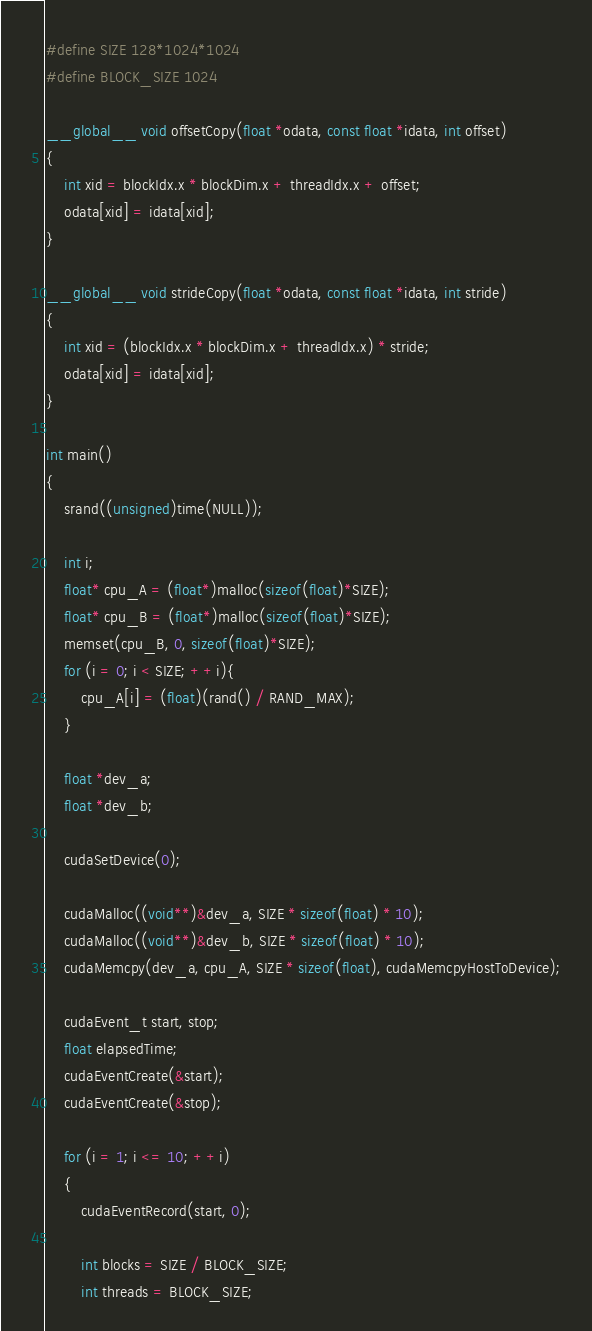Convert code to text. <code><loc_0><loc_0><loc_500><loc_500><_Cuda_>
#define SIZE 128*1024*1024
#define BLOCK_SIZE 1024

__global__ void offsetCopy(float *odata, const float *idata, int offset)
{
	int xid = blockIdx.x * blockDim.x + threadIdx.x + offset;
	odata[xid] = idata[xid];
}

__global__ void strideCopy(float *odata, const float *idata, int stride)
{
	int xid = (blockIdx.x * blockDim.x + threadIdx.x) * stride;
	odata[xid] = idata[xid];
}

int main()
{
	srand((unsigned)time(NULL));
	
	int i;
	float* cpu_A = (float*)malloc(sizeof(float)*SIZE);
	float* cpu_B = (float*)malloc(sizeof(float)*SIZE);
	memset(cpu_B, 0, sizeof(float)*SIZE);
	for (i = 0; i < SIZE; ++i){
		cpu_A[i] = (float)(rand() / RAND_MAX);
	}

	float *dev_a;
	float *dev_b;

	cudaSetDevice(0);

	cudaMalloc((void**)&dev_a, SIZE * sizeof(float) * 10);
	cudaMalloc((void**)&dev_b, SIZE * sizeof(float) * 10);
	cudaMemcpy(dev_a, cpu_A, SIZE * sizeof(float), cudaMemcpyHostToDevice);

	cudaEvent_t start, stop;
	float elapsedTime;
	cudaEventCreate(&start);
	cudaEventCreate(&stop);

	for (i = 1; i <= 10; ++i)
	{
		cudaEventRecord(start, 0);
		
		int blocks = SIZE / BLOCK_SIZE;
		int threads = BLOCK_SIZE;</code> 